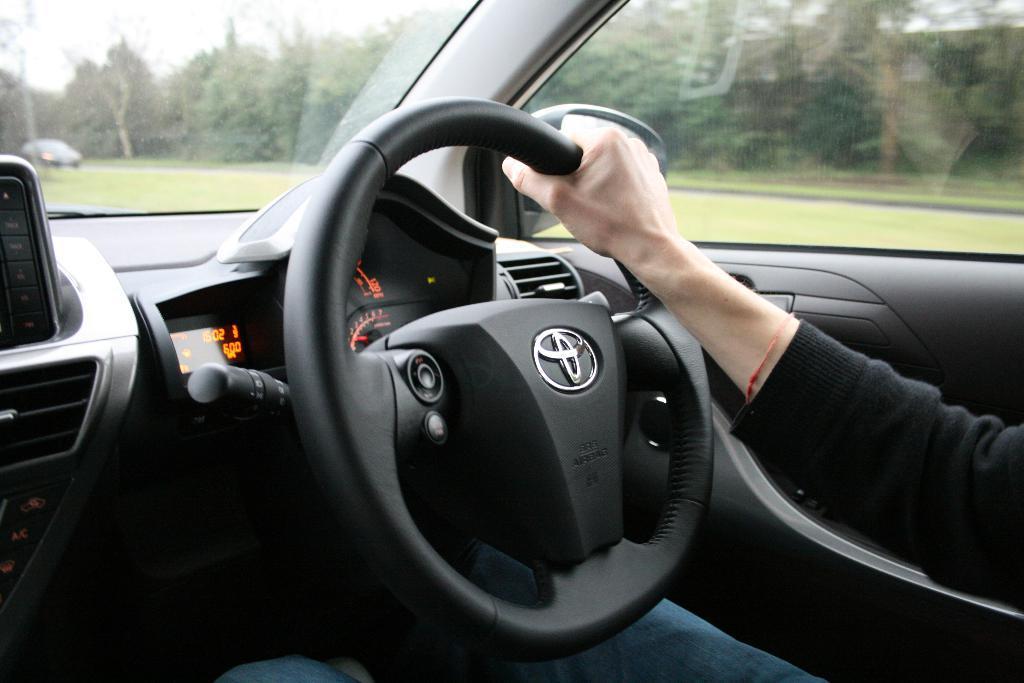How would you summarize this image in a sentence or two? In this image I can see a hand of a person is holding black colour steering. I can also see a logo, digital speedometer and in the background I can see number of trees. I can also see a vehicle over there. 